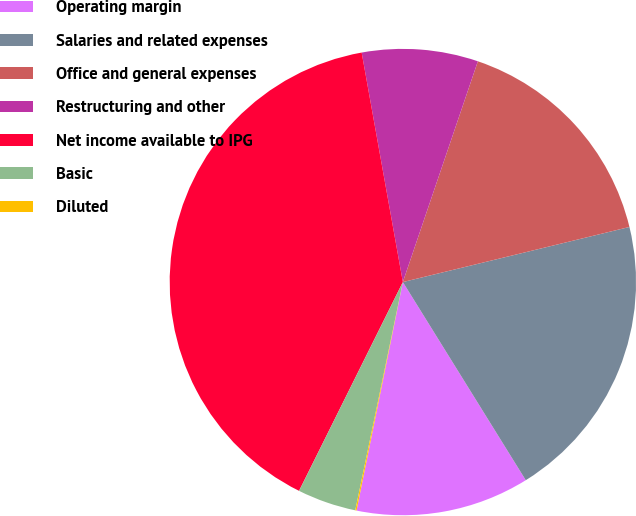<chart> <loc_0><loc_0><loc_500><loc_500><pie_chart><fcel>Operating margin<fcel>Salaries and related expenses<fcel>Office and general expenses<fcel>Restructuring and other<fcel>Net income available to IPG<fcel>Basic<fcel>Diluted<nl><fcel>12.02%<fcel>19.96%<fcel>15.99%<fcel>8.04%<fcel>39.83%<fcel>4.07%<fcel>0.09%<nl></chart> 